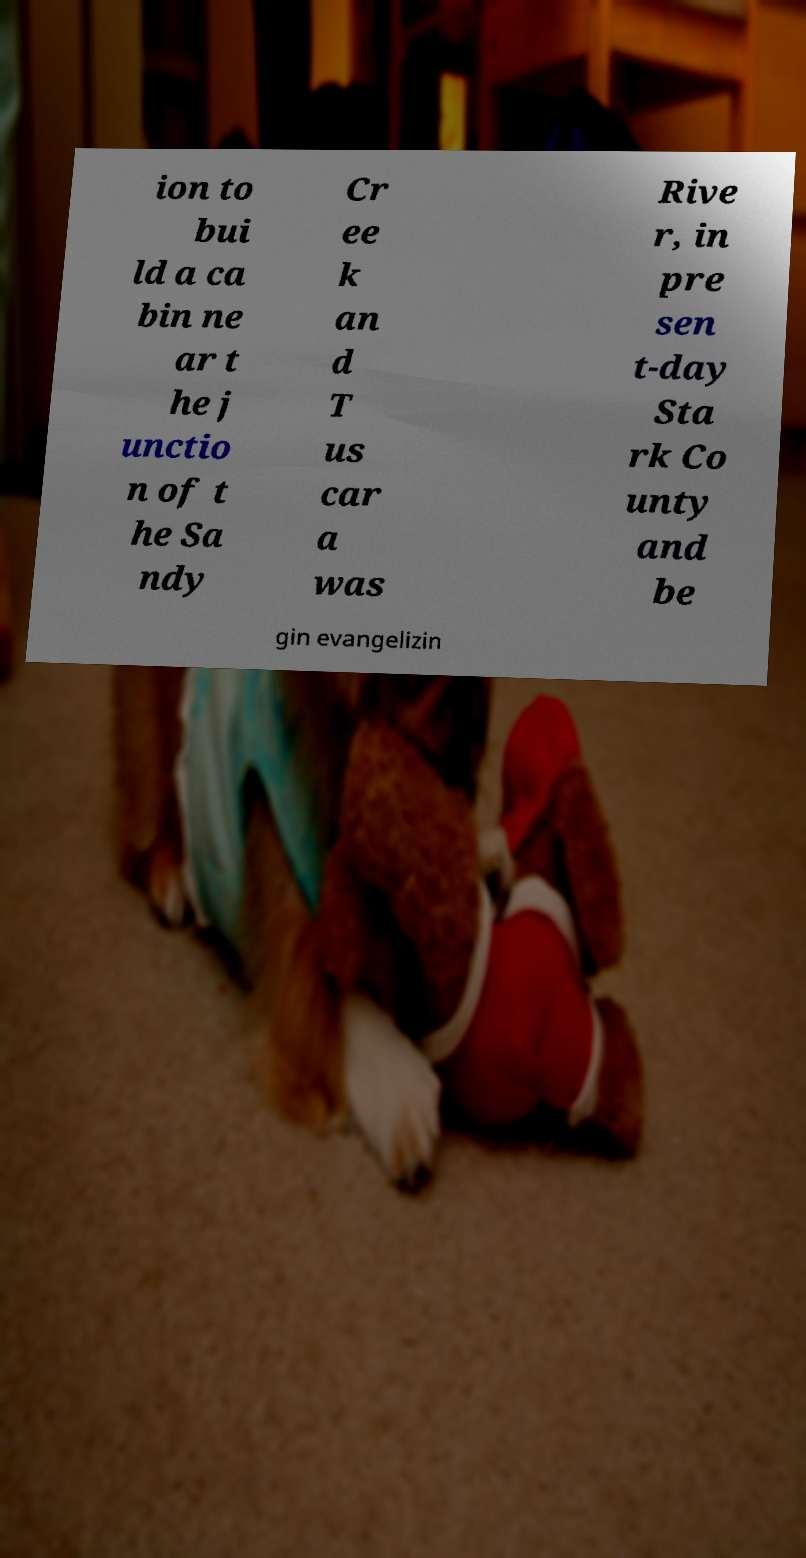Please read and relay the text visible in this image. What does it say? ion to bui ld a ca bin ne ar t he j unctio n of t he Sa ndy Cr ee k an d T us car a was Rive r, in pre sen t-day Sta rk Co unty and be gin evangelizin 